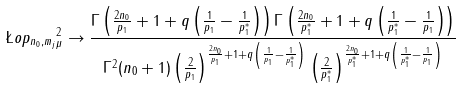<formula> <loc_0><loc_0><loc_500><loc_500>\| \L o p _ { n _ { 0 } , m _ { j } } \| _ { \mu } ^ { 2 } \to \frac { \Gamma \left ( \frac { 2 n _ { 0 } } { p _ { 1 } } + 1 + q \left ( \frac { 1 } { p _ { 1 } } - \frac { 1 } { p _ { 1 } ^ { * } } \right ) \right ) \Gamma \left ( \frac { 2 n _ { 0 } } { p _ { 1 } ^ { * } } + 1 + q \left ( \frac { 1 } { p _ { 1 } ^ { * } } - \frac { 1 } { p _ { 1 } } \right ) \right ) } { \Gamma ^ { 2 } ( n _ { 0 } + 1 ) \left ( \frac { 2 } { p _ { 1 } } \right ) ^ { \frac { 2 n _ { 0 } } { p _ { 1 } } + 1 + q \left ( \frac { 1 } { p _ { 1 } } - \frac { 1 } { p _ { 1 } ^ { * } } \right ) } \left ( \frac { 2 } { p _ { 1 } ^ { * } } \right ) ^ { \frac { 2 n _ { 0 } } { p _ { 1 } ^ { * } } + 1 + q \left ( \frac { 1 } { p _ { 1 } ^ { * } } - \frac { 1 } { p _ { 1 } } \right ) } }</formula> 